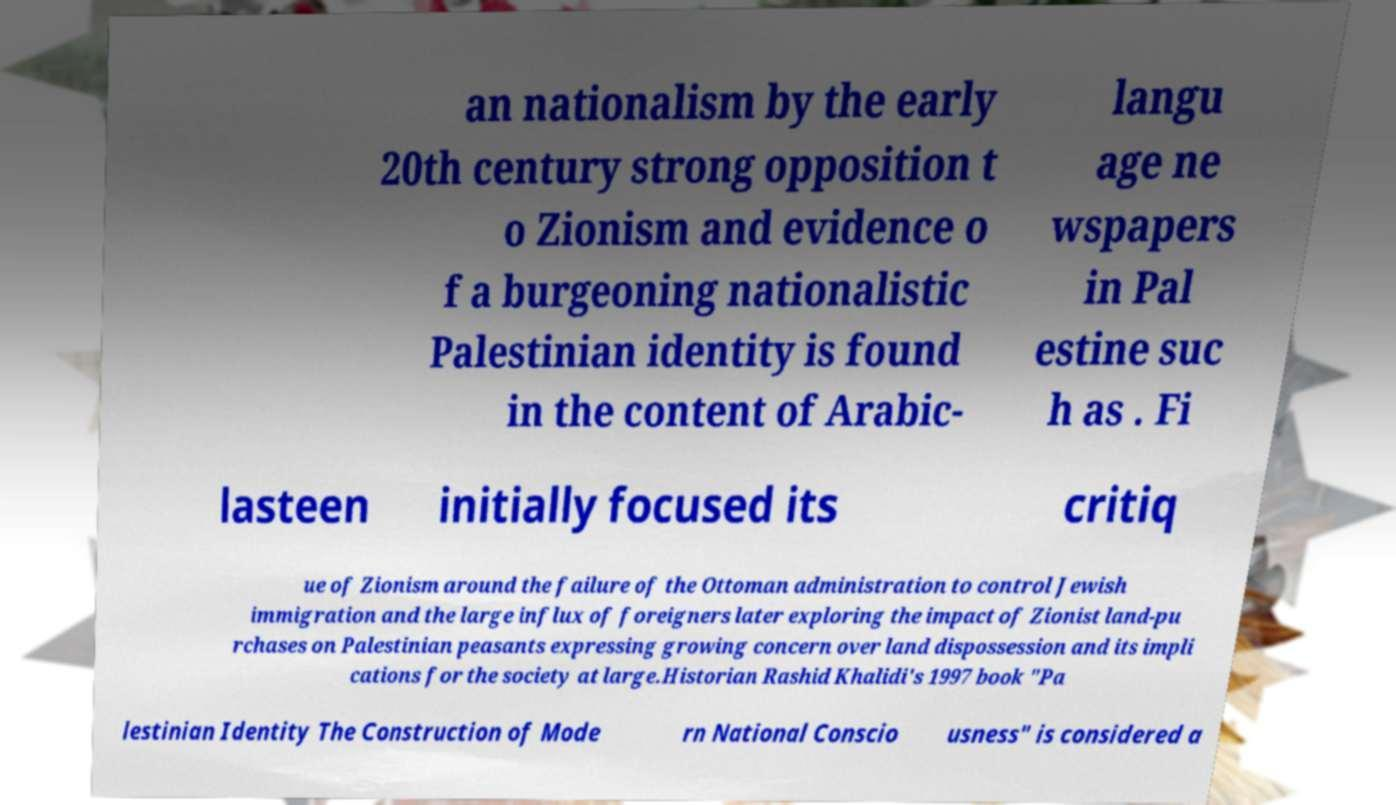For documentation purposes, I need the text within this image transcribed. Could you provide that? an nationalism by the early 20th century strong opposition t o Zionism and evidence o f a burgeoning nationalistic Palestinian identity is found in the content of Arabic- langu age ne wspapers in Pal estine suc h as . Fi lasteen initially focused its critiq ue of Zionism around the failure of the Ottoman administration to control Jewish immigration and the large influx of foreigners later exploring the impact of Zionist land-pu rchases on Palestinian peasants expressing growing concern over land dispossession and its impli cations for the society at large.Historian Rashid Khalidi's 1997 book "Pa lestinian Identity The Construction of Mode rn National Conscio usness" is considered a 